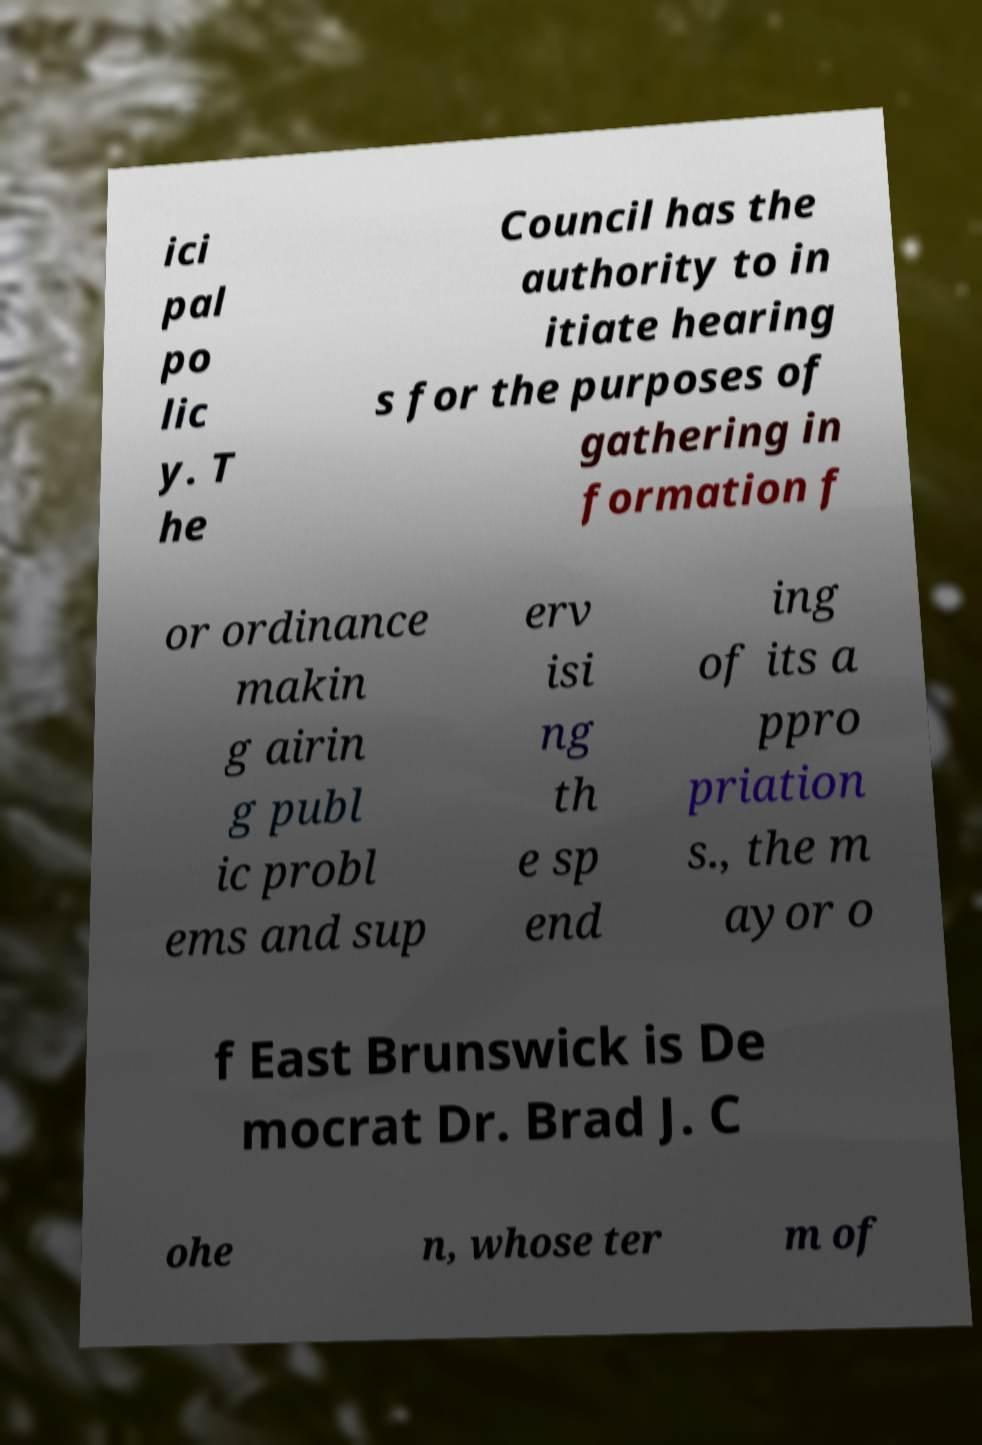Can you read and provide the text displayed in the image?This photo seems to have some interesting text. Can you extract and type it out for me? ici pal po lic y. T he Council has the authority to in itiate hearing s for the purposes of gathering in formation f or ordinance makin g airin g publ ic probl ems and sup erv isi ng th e sp end ing of its a ppro priation s., the m ayor o f East Brunswick is De mocrat Dr. Brad J. C ohe n, whose ter m of 